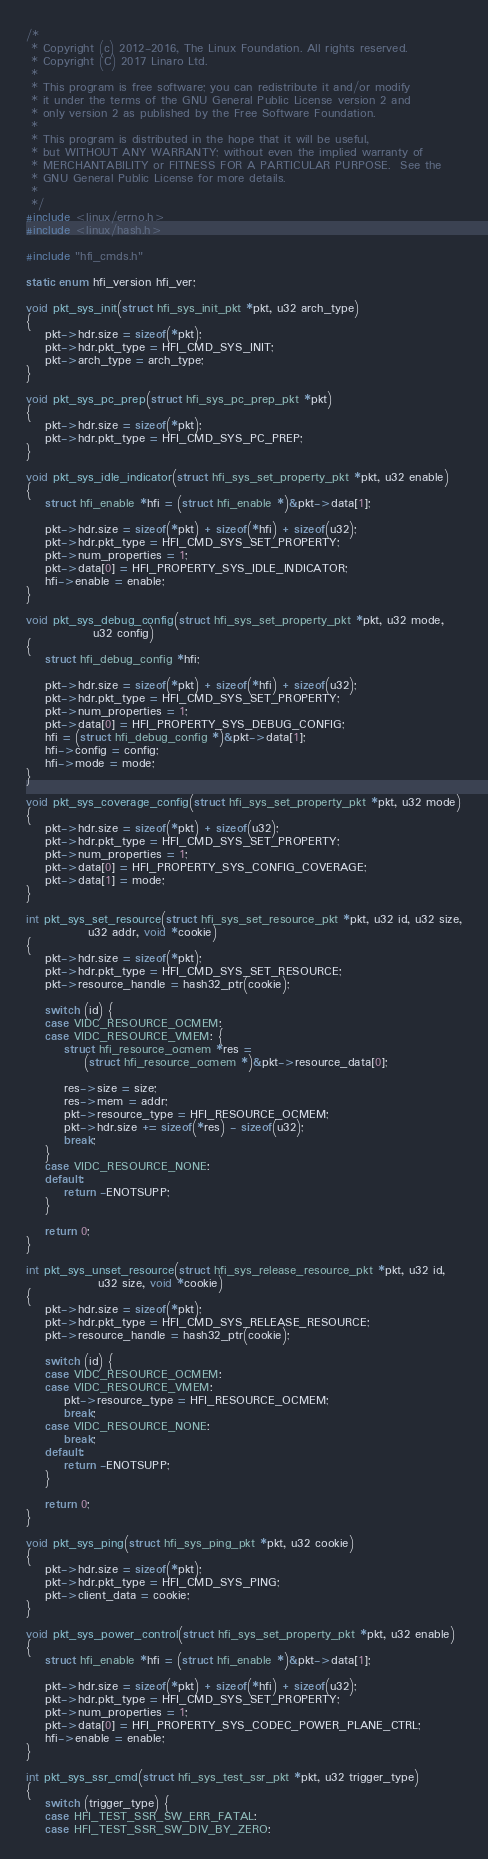Convert code to text. <code><loc_0><loc_0><loc_500><loc_500><_C_>/*
 * Copyright (c) 2012-2016, The Linux Foundation. All rights reserved.
 * Copyright (C) 2017 Linaro Ltd.
 *
 * This program is free software; you can redistribute it and/or modify
 * it under the terms of the GNU General Public License version 2 and
 * only version 2 as published by the Free Software Foundation.
 *
 * This program is distributed in the hope that it will be useful,
 * but WITHOUT ANY WARRANTY; without even the implied warranty of
 * MERCHANTABILITY or FITNESS FOR A PARTICULAR PURPOSE.  See the
 * GNU General Public License for more details.
 *
 */
#include <linux/errno.h>
#include <linux/hash.h>

#include "hfi_cmds.h"

static enum hfi_version hfi_ver;

void pkt_sys_init(struct hfi_sys_init_pkt *pkt, u32 arch_type)
{
	pkt->hdr.size = sizeof(*pkt);
	pkt->hdr.pkt_type = HFI_CMD_SYS_INIT;
	pkt->arch_type = arch_type;
}

void pkt_sys_pc_prep(struct hfi_sys_pc_prep_pkt *pkt)
{
	pkt->hdr.size = sizeof(*pkt);
	pkt->hdr.pkt_type = HFI_CMD_SYS_PC_PREP;
}

void pkt_sys_idle_indicator(struct hfi_sys_set_property_pkt *pkt, u32 enable)
{
	struct hfi_enable *hfi = (struct hfi_enable *)&pkt->data[1];

	pkt->hdr.size = sizeof(*pkt) + sizeof(*hfi) + sizeof(u32);
	pkt->hdr.pkt_type = HFI_CMD_SYS_SET_PROPERTY;
	pkt->num_properties = 1;
	pkt->data[0] = HFI_PROPERTY_SYS_IDLE_INDICATOR;
	hfi->enable = enable;
}

void pkt_sys_debug_config(struct hfi_sys_set_property_pkt *pkt, u32 mode,
			  u32 config)
{
	struct hfi_debug_config *hfi;

	pkt->hdr.size = sizeof(*pkt) + sizeof(*hfi) + sizeof(u32);
	pkt->hdr.pkt_type = HFI_CMD_SYS_SET_PROPERTY;
	pkt->num_properties = 1;
	pkt->data[0] = HFI_PROPERTY_SYS_DEBUG_CONFIG;
	hfi = (struct hfi_debug_config *)&pkt->data[1];
	hfi->config = config;
	hfi->mode = mode;
}

void pkt_sys_coverage_config(struct hfi_sys_set_property_pkt *pkt, u32 mode)
{
	pkt->hdr.size = sizeof(*pkt) + sizeof(u32);
	pkt->hdr.pkt_type = HFI_CMD_SYS_SET_PROPERTY;
	pkt->num_properties = 1;
	pkt->data[0] = HFI_PROPERTY_SYS_CONFIG_COVERAGE;
	pkt->data[1] = mode;
}

int pkt_sys_set_resource(struct hfi_sys_set_resource_pkt *pkt, u32 id, u32 size,
			 u32 addr, void *cookie)
{
	pkt->hdr.size = sizeof(*pkt);
	pkt->hdr.pkt_type = HFI_CMD_SYS_SET_RESOURCE;
	pkt->resource_handle = hash32_ptr(cookie);

	switch (id) {
	case VIDC_RESOURCE_OCMEM:
	case VIDC_RESOURCE_VMEM: {
		struct hfi_resource_ocmem *res =
			(struct hfi_resource_ocmem *)&pkt->resource_data[0];

		res->size = size;
		res->mem = addr;
		pkt->resource_type = HFI_RESOURCE_OCMEM;
		pkt->hdr.size += sizeof(*res) - sizeof(u32);
		break;
	}
	case VIDC_RESOURCE_NONE:
	default:
		return -ENOTSUPP;
	}

	return 0;
}

int pkt_sys_unset_resource(struct hfi_sys_release_resource_pkt *pkt, u32 id,
			   u32 size, void *cookie)
{
	pkt->hdr.size = sizeof(*pkt);
	pkt->hdr.pkt_type = HFI_CMD_SYS_RELEASE_RESOURCE;
	pkt->resource_handle = hash32_ptr(cookie);

	switch (id) {
	case VIDC_RESOURCE_OCMEM:
	case VIDC_RESOURCE_VMEM:
		pkt->resource_type = HFI_RESOURCE_OCMEM;
		break;
	case VIDC_RESOURCE_NONE:
		break;
	default:
		return -ENOTSUPP;
	}

	return 0;
}

void pkt_sys_ping(struct hfi_sys_ping_pkt *pkt, u32 cookie)
{
	pkt->hdr.size = sizeof(*pkt);
	pkt->hdr.pkt_type = HFI_CMD_SYS_PING;
	pkt->client_data = cookie;
}

void pkt_sys_power_control(struct hfi_sys_set_property_pkt *pkt, u32 enable)
{
	struct hfi_enable *hfi = (struct hfi_enable *)&pkt->data[1];

	pkt->hdr.size = sizeof(*pkt) + sizeof(*hfi) + sizeof(u32);
	pkt->hdr.pkt_type = HFI_CMD_SYS_SET_PROPERTY;
	pkt->num_properties = 1;
	pkt->data[0] = HFI_PROPERTY_SYS_CODEC_POWER_PLANE_CTRL;
	hfi->enable = enable;
}

int pkt_sys_ssr_cmd(struct hfi_sys_test_ssr_pkt *pkt, u32 trigger_type)
{
	switch (trigger_type) {
	case HFI_TEST_SSR_SW_ERR_FATAL:
	case HFI_TEST_SSR_SW_DIV_BY_ZERO:</code> 